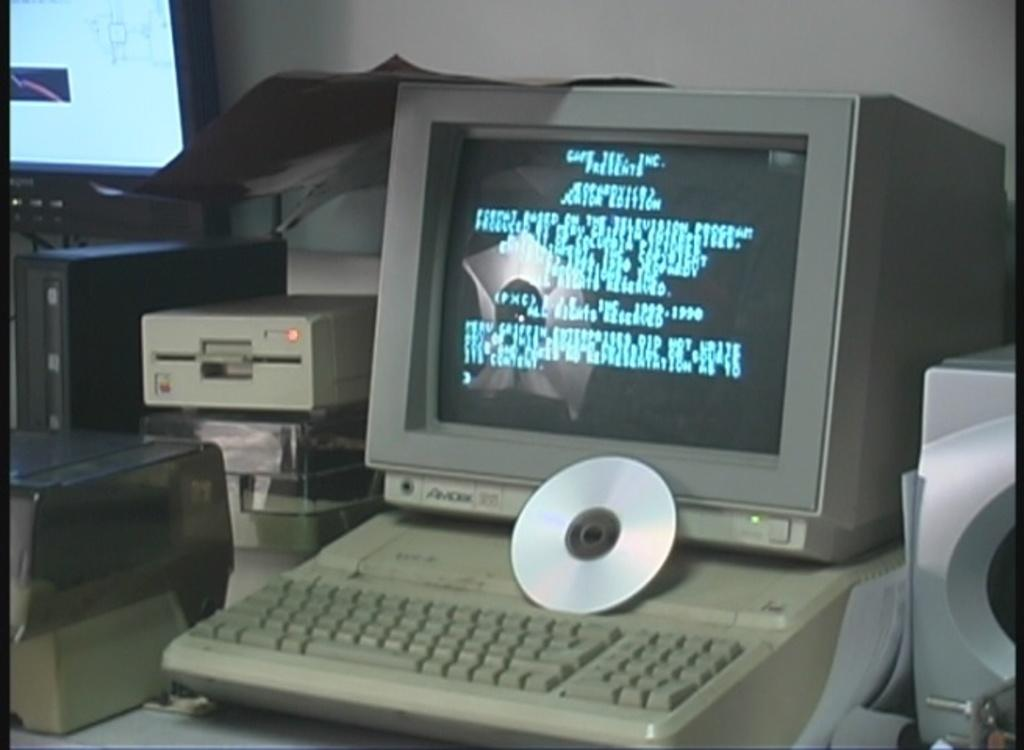What is the main object in the image? There is a computer in the image. What is placed on the computer? A compact disc is visible on the computer. What other electronic devices are present in the image? There are other electronic devices around the computer. What can be seen in the background of the image? There is a wall in the background of the image. What type of cap is the yam wearing in the image? There is no yam or cap present in the image; it only features a computer and other electronic devices. 